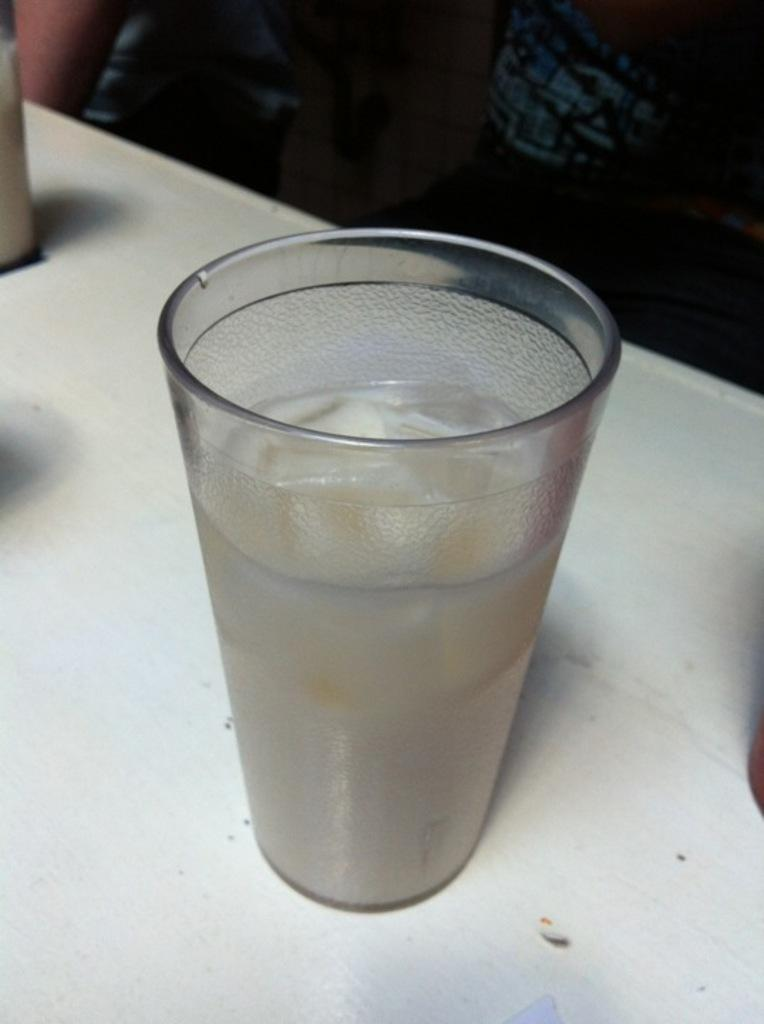What object in the image contains a liquid? The glass in the image contains a liquid. Where is the glass located in the image? The glass is placed on a table. What type of growth can be seen on the rim of the glass in the image? There is no visible growth on the rim of the glass in the image. What is covering the top of the glass in the image? There is no cover present on the top of the glass in the image. 